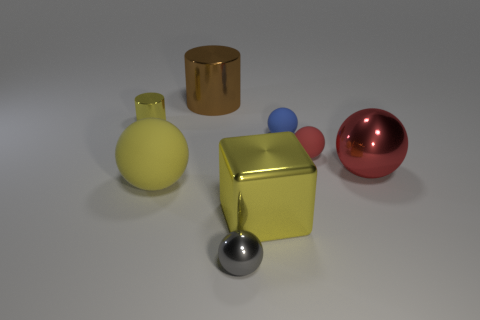What shape is the tiny object that is the same color as the large metal block?
Ensure brevity in your answer.  Cylinder. The other shiny thing that is the same shape as the gray metal thing is what color?
Offer a terse response. Red. What number of tiny matte spheres have the same color as the small shiny sphere?
Your answer should be very brief. 0. There is a tiny blue thing in front of the large metal cylinder; is there a big sphere behind it?
Make the answer very short. No. What number of yellow metal objects are in front of the blue ball and on the left side of the large yellow matte ball?
Provide a short and direct response. 0. What number of large things are the same material as the tiny gray ball?
Make the answer very short. 3. How big is the yellow metallic thing behind the big yellow thing that is to the right of the small gray thing?
Offer a very short reply. Small. Are there any small gray metallic objects of the same shape as the brown object?
Provide a short and direct response. No. Do the metallic cylinder that is behind the tiny yellow metal cylinder and the yellow thing that is behind the small blue matte object have the same size?
Ensure brevity in your answer.  No. Are there fewer yellow cubes that are to the right of the big matte sphere than metal blocks that are on the right side of the big block?
Offer a very short reply. No. 